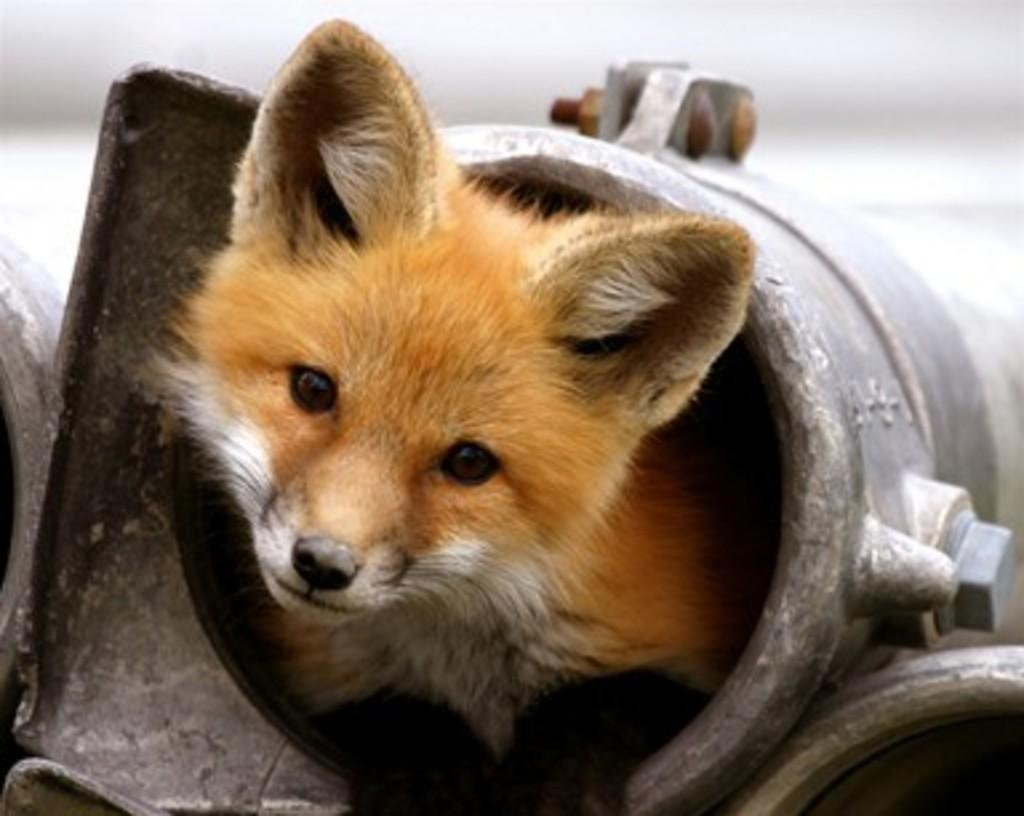What is the main subject of the image? There is an animal in a metal object in the image. Can you describe the background of the image? The background of the image is blurry. How many rocks can be seen in the image? There are no rocks present in the image. What type of jellyfish is swimming in the metal object in the image? There is no jellyfish present in the image; it features an animal in a metal object. 